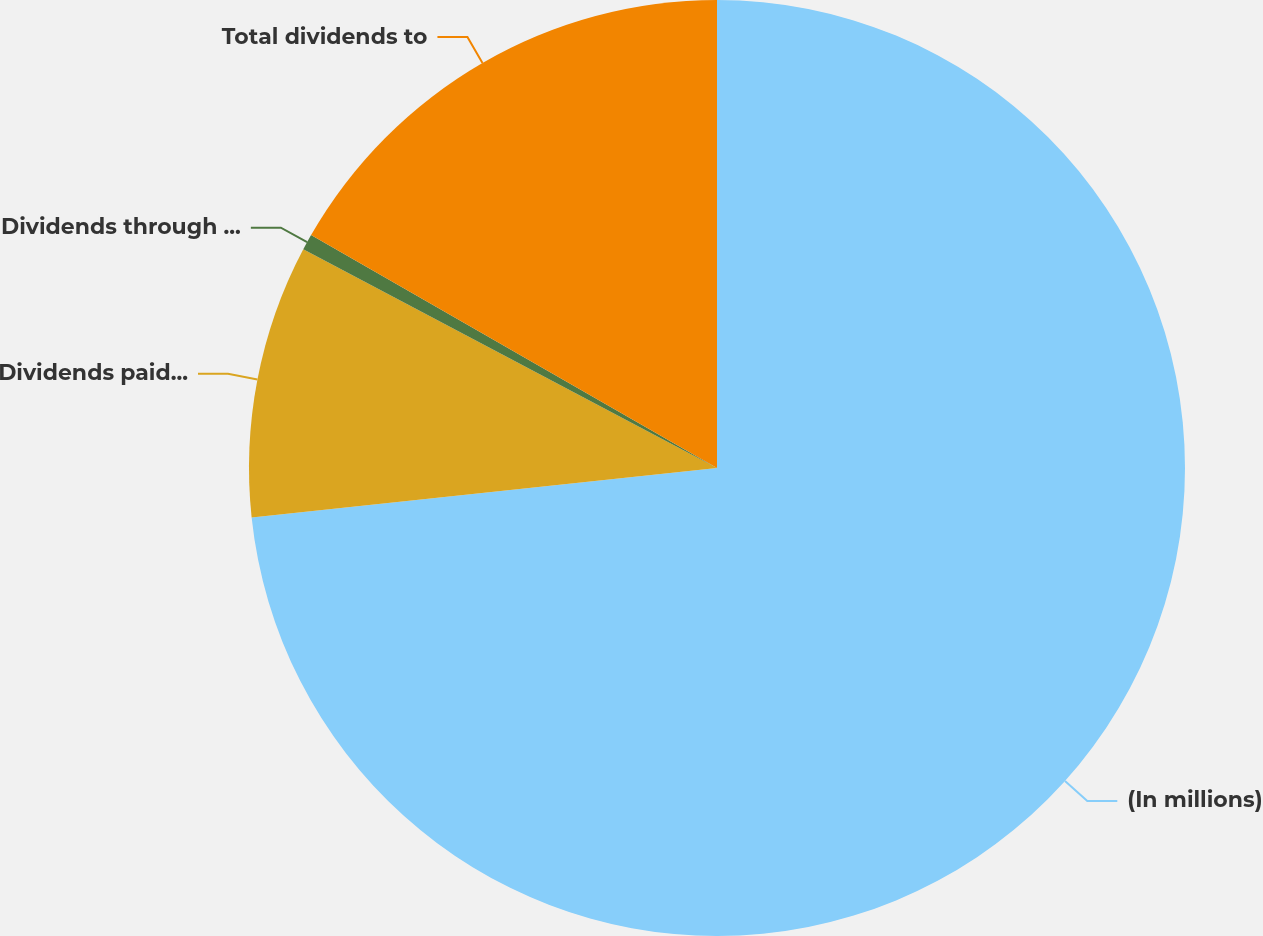Convert chart. <chart><loc_0><loc_0><loc_500><loc_500><pie_chart><fcel>(In millions)<fcel>Dividends paid in cash<fcel>Dividends through issuance of<fcel>Total dividends to<nl><fcel>73.32%<fcel>9.43%<fcel>0.55%<fcel>16.71%<nl></chart> 